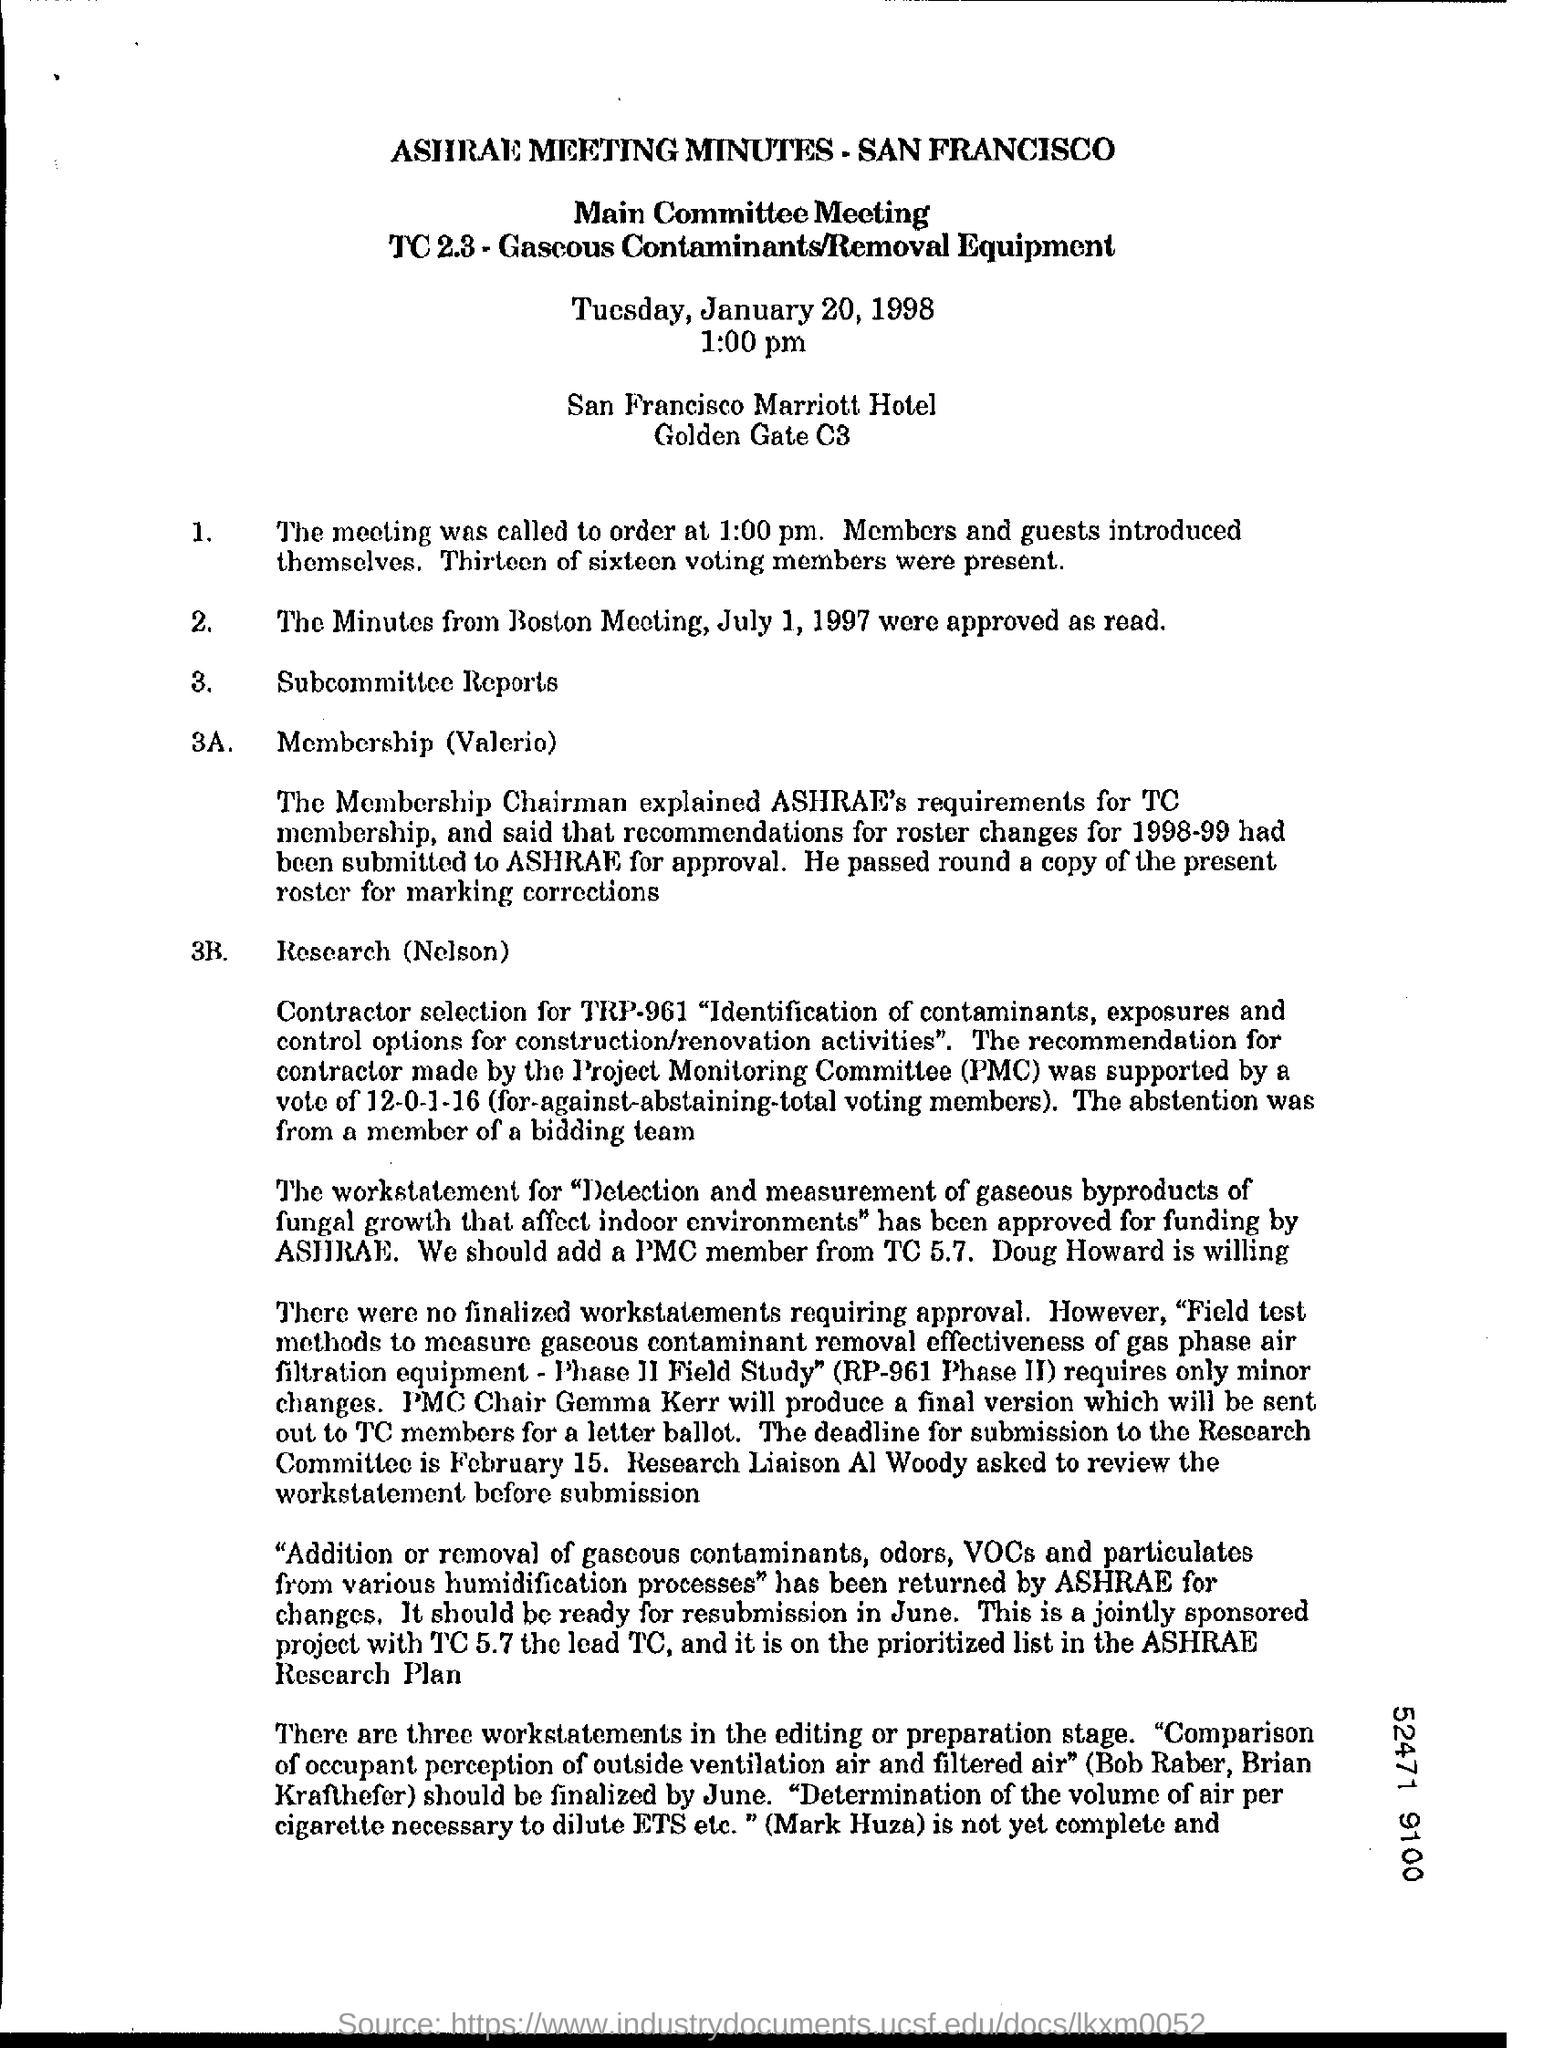What is time mentioned in this document?
Keep it short and to the point. 1.00 pm. Who introduced members and guests?
Make the answer very short. Themselves. Which day's minutes was approved?
Offer a terse response. July 1, 1997. Who explained about the requirements?
Offer a terse response. Membership Chairman. 